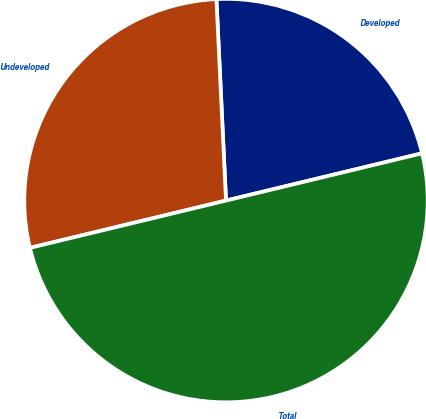Convert chart. <chart><loc_0><loc_0><loc_500><loc_500><pie_chart><fcel>Developed<fcel>Undeveloped<fcel>Total<nl><fcel>21.99%<fcel>28.01%<fcel>50.0%<nl></chart> 